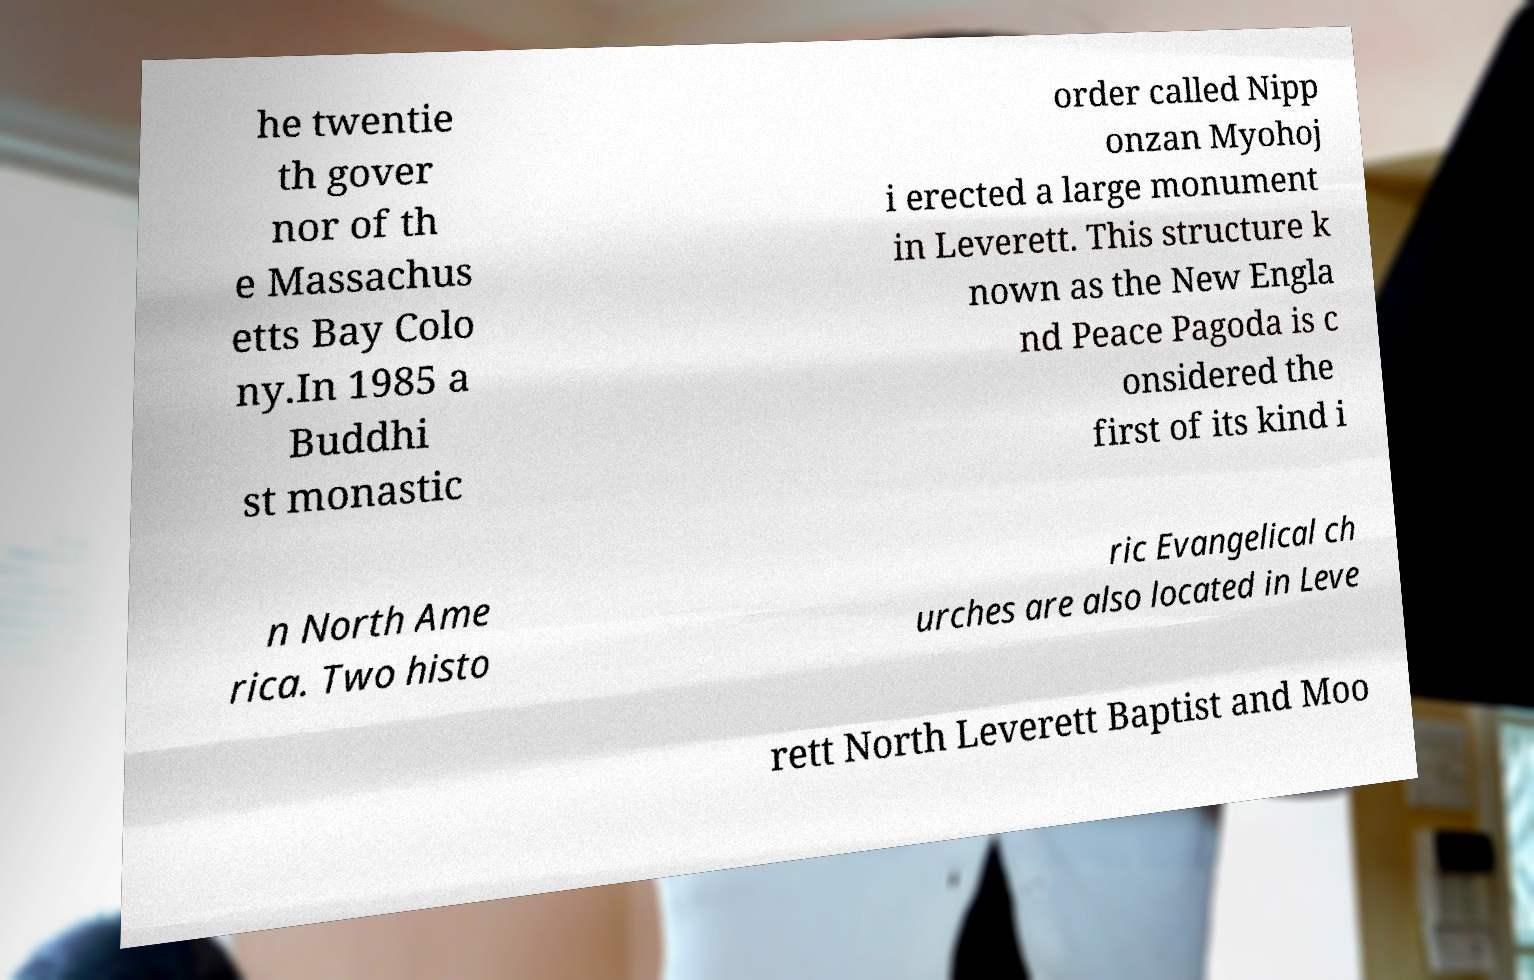There's text embedded in this image that I need extracted. Can you transcribe it verbatim? he twentie th gover nor of th e Massachus etts Bay Colo ny.In 1985 a Buddhi st monastic order called Nipp onzan Myohoj i erected a large monument in Leverett. This structure k nown as the New Engla nd Peace Pagoda is c onsidered the first of its kind i n North Ame rica. Two histo ric Evangelical ch urches are also located in Leve rett North Leverett Baptist and Moo 